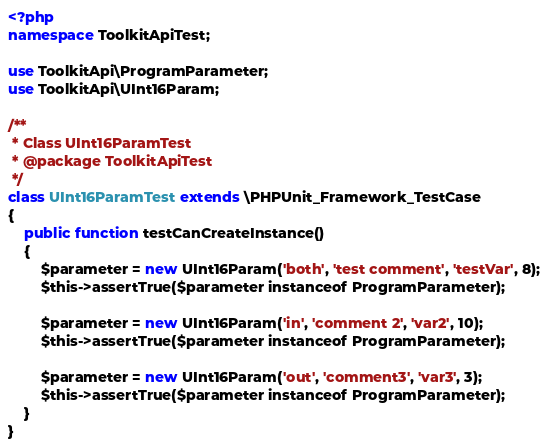Convert code to text. <code><loc_0><loc_0><loc_500><loc_500><_PHP_><?php
namespace ToolkitApiTest;

use ToolkitApi\ProgramParameter;
use ToolkitApi\UInt16Param;

/**
 * Class UInt16ParamTest
 * @package ToolkitApiTest
 */
class UInt16ParamTest extends \PHPUnit_Framework_TestCase
{
    public function testCanCreateInstance()
    {
        $parameter = new UInt16Param('both', 'test comment', 'testVar', 8);
        $this->assertTrue($parameter instanceof ProgramParameter);

        $parameter = new UInt16Param('in', 'comment 2', 'var2', 10);
        $this->assertTrue($parameter instanceof ProgramParameter);

        $parameter = new UInt16Param('out', 'comment3', 'var3', 3);
        $this->assertTrue($parameter instanceof ProgramParameter);
    }
}</code> 